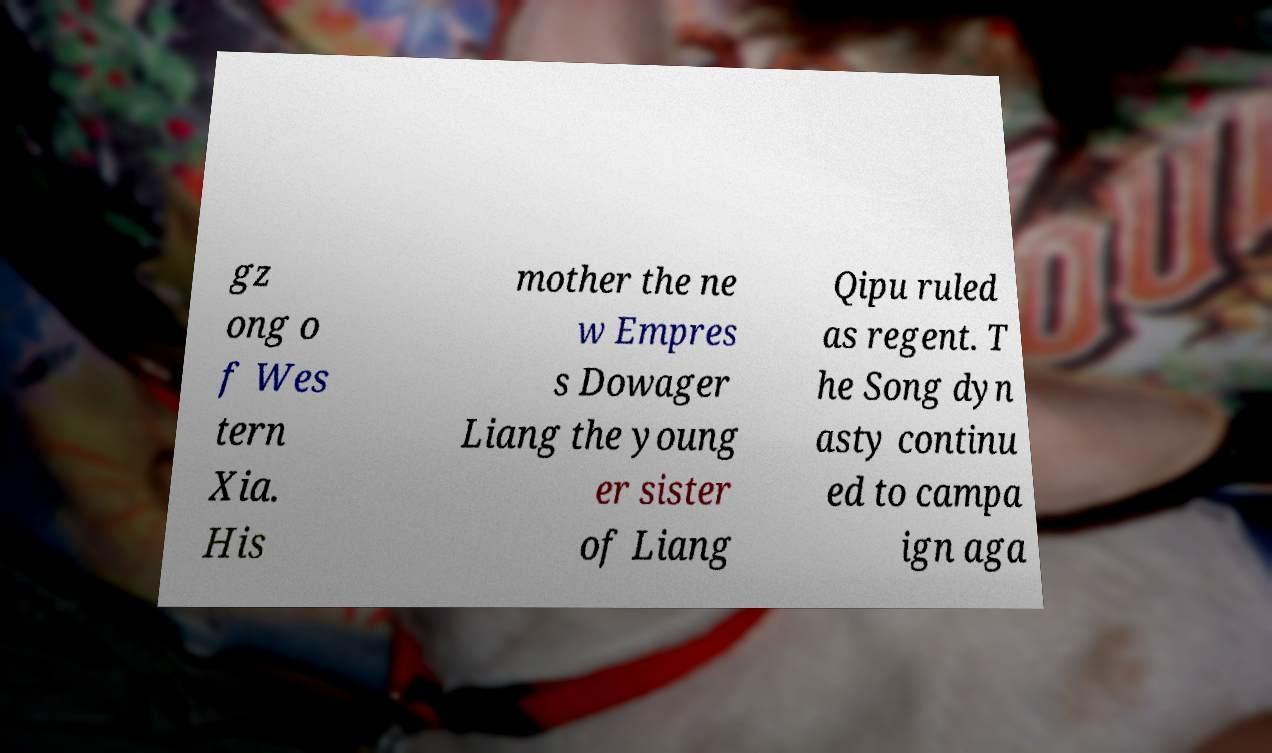I need the written content from this picture converted into text. Can you do that? gz ong o f Wes tern Xia. His mother the ne w Empres s Dowager Liang the young er sister of Liang Qipu ruled as regent. T he Song dyn asty continu ed to campa ign aga 